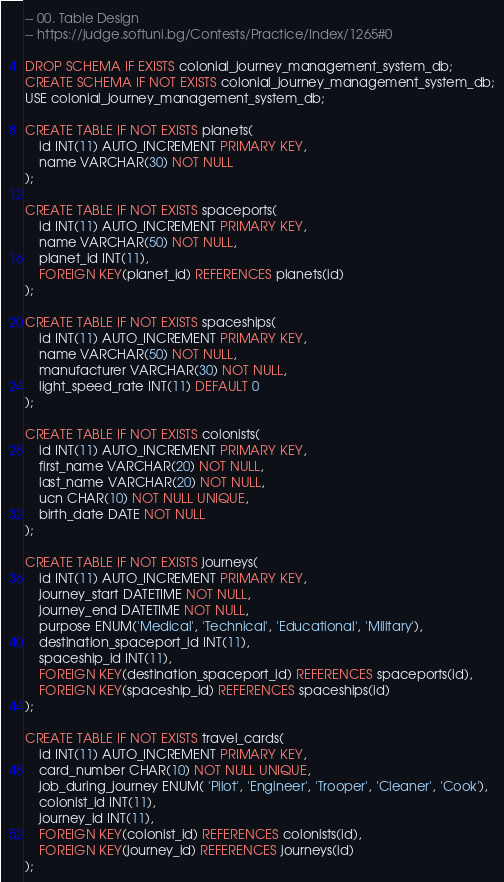<code> <loc_0><loc_0><loc_500><loc_500><_SQL_>-- 00. Table Design
-- https://judge.softuni.bg/Contests/Practice/Index/1265#0

DROP SCHEMA IF EXISTS colonial_journey_management_system_db;
CREATE SCHEMA IF NOT EXISTS colonial_journey_management_system_db;
USE colonial_journey_management_system_db;

CREATE TABLE IF NOT EXISTS planets(
	id INT(11) AUTO_INCREMENT PRIMARY KEY,
    name VARCHAR(30) NOT NULL
);

CREATE TABLE IF NOT EXISTS spaceports(
	id INT(11) AUTO_INCREMENT PRIMARY KEY,
    name VARCHAR(50) NOT NULL,
    planet_id INT(11),
    FOREIGN KEY(planet_id) REFERENCES planets(id)
);

CREATE TABLE IF NOT EXISTS spaceships(
	id INT(11) AUTO_INCREMENT PRIMARY KEY,
    name VARCHAR(50) NOT NULL,
    manufacturer VARCHAR(30) NOT NULL,
    light_speed_rate INT(11) DEFAULT 0
);

CREATE TABLE IF NOT EXISTS colonists(
	id INT(11) AUTO_INCREMENT PRIMARY KEY,
    first_name VARCHAR(20) NOT NULL,
    last_name VARCHAR(20) NOT NULL,
    ucn CHAR(10) NOT NULL UNIQUE,
    birth_date DATE NOT NULL
);

CREATE TABLE IF NOT EXISTS journeys(
	id INT(11) AUTO_INCREMENT PRIMARY KEY,
    journey_start DATETIME NOT NULL,
    journey_end DATETIME NOT NULL,
    purpose ENUM('Medical', 'Technical', 'Educational', 'Military'),
    destination_spaceport_id INT(11),
    spaceship_id INT(11),
    FOREIGN KEY(destination_spaceport_id) REFERENCES spaceports(id),
    FOREIGN KEY(spaceship_id) REFERENCES spaceships(id)
);

CREATE TABLE IF NOT EXISTS travel_cards(
	id INT(11) AUTO_INCREMENT PRIMARY KEY,
    card_number CHAR(10) NOT NULL UNIQUE,
    job_during_journey ENUM( 'Pilot', 'Engineer', 'Trooper', 'Cleaner', 'Cook'),
    colonist_id INT(11),
    journey_id INT(11),
    FOREIGN KEY(colonist_id) REFERENCES colonists(id),
    FOREIGN KEY(journey_id) REFERENCES journeys(id)
);



</code> 